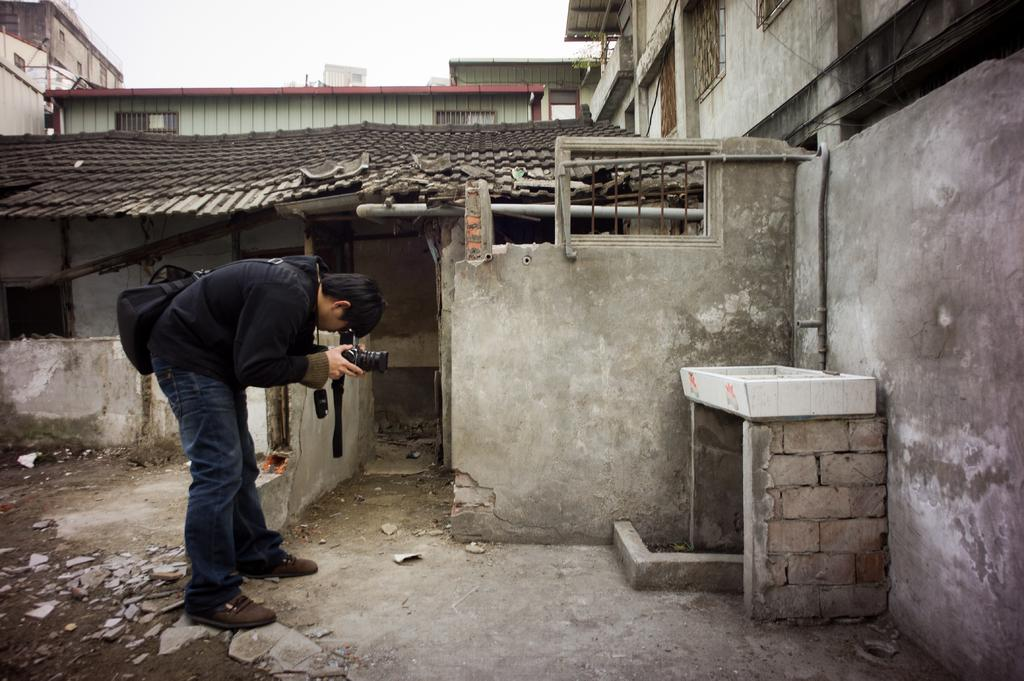What type of structures can be seen in the image? There are buildings in the image. What can be seen on the ground in the image? There is a path in the image. What is the man in the image holding? The man is holding a camera in his hands. What is the man wearing on his body? The man is wearing a bag. What is visible in the background of the image? The sky is visible in the background of the image. What type of cracker is the man eating while taking a photo in the image? There is no cracker present in the image, and the man is not shown eating anything. How does the man twist his body while holding the camera in the image? The man is not shown twisting his body in the image; he is simply holding the camera. 